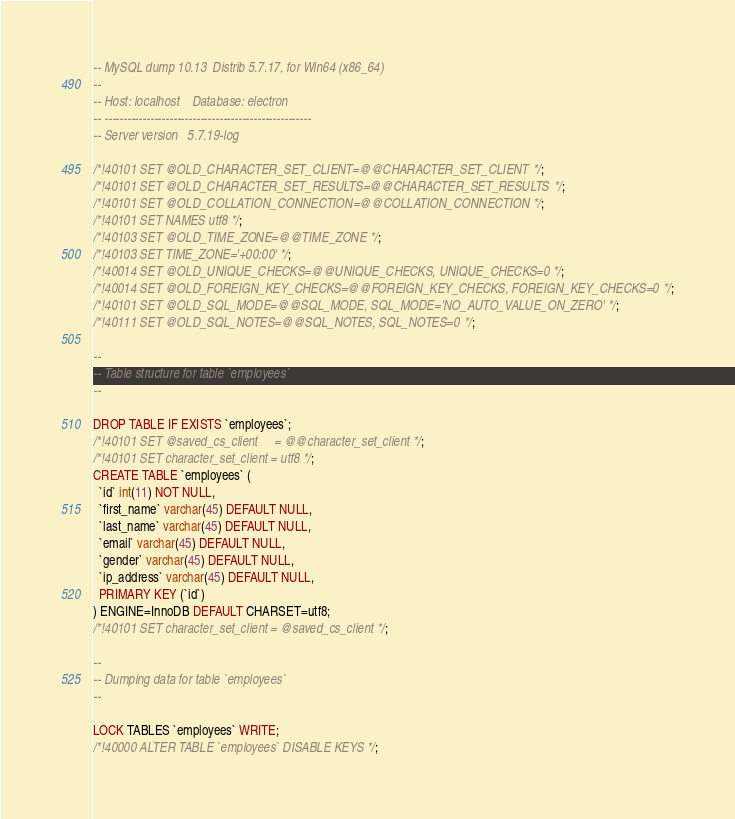Convert code to text. <code><loc_0><loc_0><loc_500><loc_500><_SQL_>-- MySQL dump 10.13  Distrib 5.7.17, for Win64 (x86_64)
--
-- Host: localhost    Database: electron
-- ------------------------------------------------------
-- Server version	5.7.19-log

/*!40101 SET @OLD_CHARACTER_SET_CLIENT=@@CHARACTER_SET_CLIENT */;
/*!40101 SET @OLD_CHARACTER_SET_RESULTS=@@CHARACTER_SET_RESULTS */;
/*!40101 SET @OLD_COLLATION_CONNECTION=@@COLLATION_CONNECTION */;
/*!40101 SET NAMES utf8 */;
/*!40103 SET @OLD_TIME_ZONE=@@TIME_ZONE */;
/*!40103 SET TIME_ZONE='+00:00' */;
/*!40014 SET @OLD_UNIQUE_CHECKS=@@UNIQUE_CHECKS, UNIQUE_CHECKS=0 */;
/*!40014 SET @OLD_FOREIGN_KEY_CHECKS=@@FOREIGN_KEY_CHECKS, FOREIGN_KEY_CHECKS=0 */;
/*!40101 SET @OLD_SQL_MODE=@@SQL_MODE, SQL_MODE='NO_AUTO_VALUE_ON_ZERO' */;
/*!40111 SET @OLD_SQL_NOTES=@@SQL_NOTES, SQL_NOTES=0 */;

--
-- Table structure for table `employees`
--

DROP TABLE IF EXISTS `employees`;
/*!40101 SET @saved_cs_client     = @@character_set_client */;
/*!40101 SET character_set_client = utf8 */;
CREATE TABLE `employees` (
  `id` int(11) NOT NULL,
  `first_name` varchar(45) DEFAULT NULL,
  `last_name` varchar(45) DEFAULT NULL,
  `email` varchar(45) DEFAULT NULL,
  `gender` varchar(45) DEFAULT NULL,
  `ip_address` varchar(45) DEFAULT NULL,
  PRIMARY KEY (`id`)
) ENGINE=InnoDB DEFAULT CHARSET=utf8;
/*!40101 SET character_set_client = @saved_cs_client */;

--
-- Dumping data for table `employees`
--

LOCK TABLES `employees` WRITE;
/*!40000 ALTER TABLE `employees` DISABLE KEYS */;</code> 